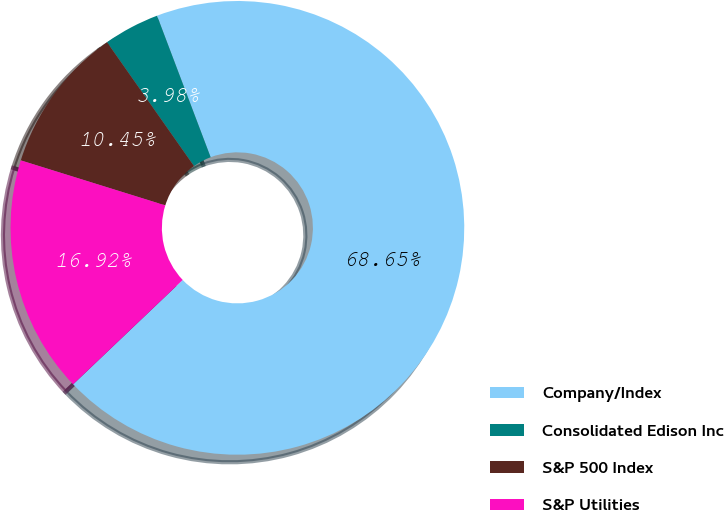<chart> <loc_0><loc_0><loc_500><loc_500><pie_chart><fcel>Company/Index<fcel>Consolidated Edison Inc<fcel>S&P 500 Index<fcel>S&P Utilities<nl><fcel>68.65%<fcel>3.98%<fcel>10.45%<fcel>16.92%<nl></chart> 